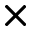<formula> <loc_0><loc_0><loc_500><loc_500>\times</formula> 